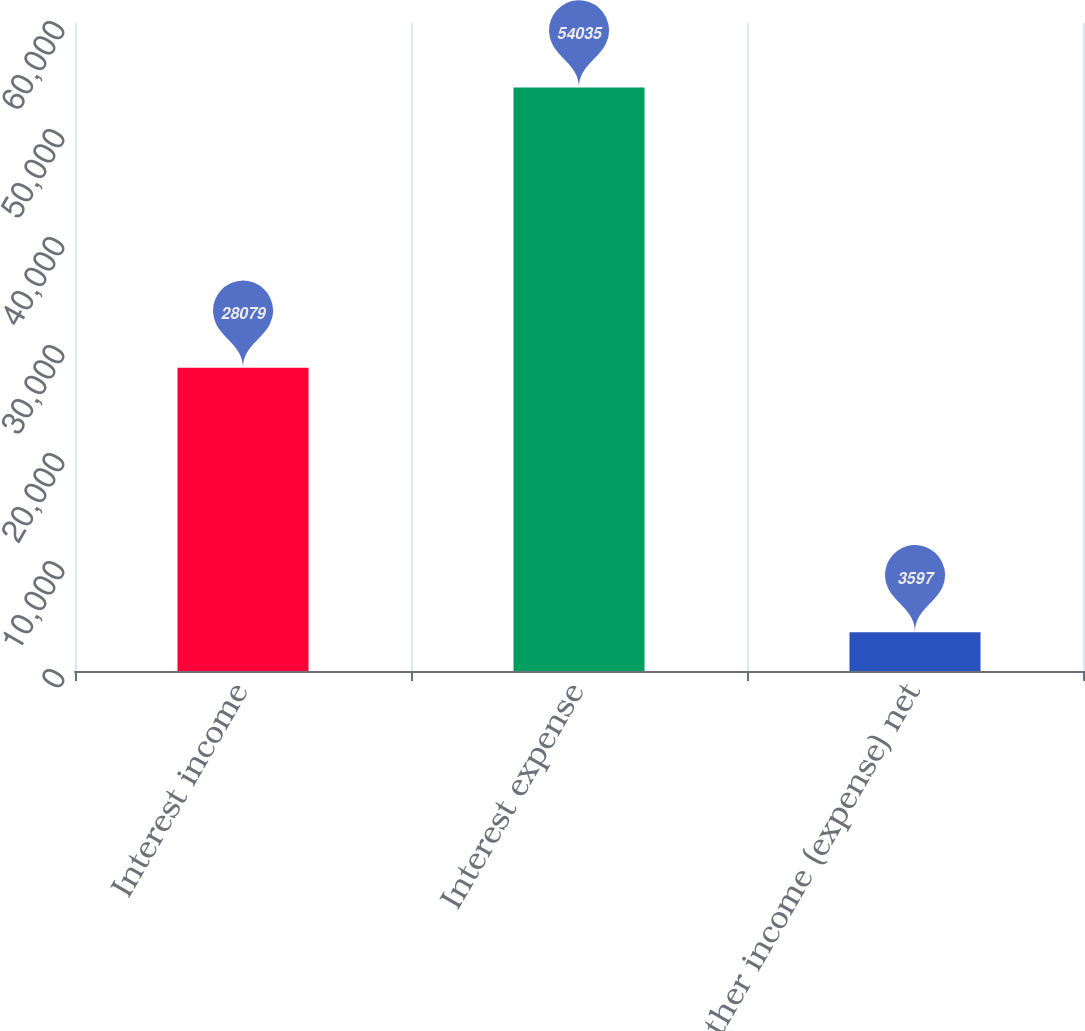Convert chart to OTSL. <chart><loc_0><loc_0><loc_500><loc_500><bar_chart><fcel>Interest income<fcel>Interest expense<fcel>Other income (expense) net<nl><fcel>28079<fcel>54035<fcel>3597<nl></chart> 